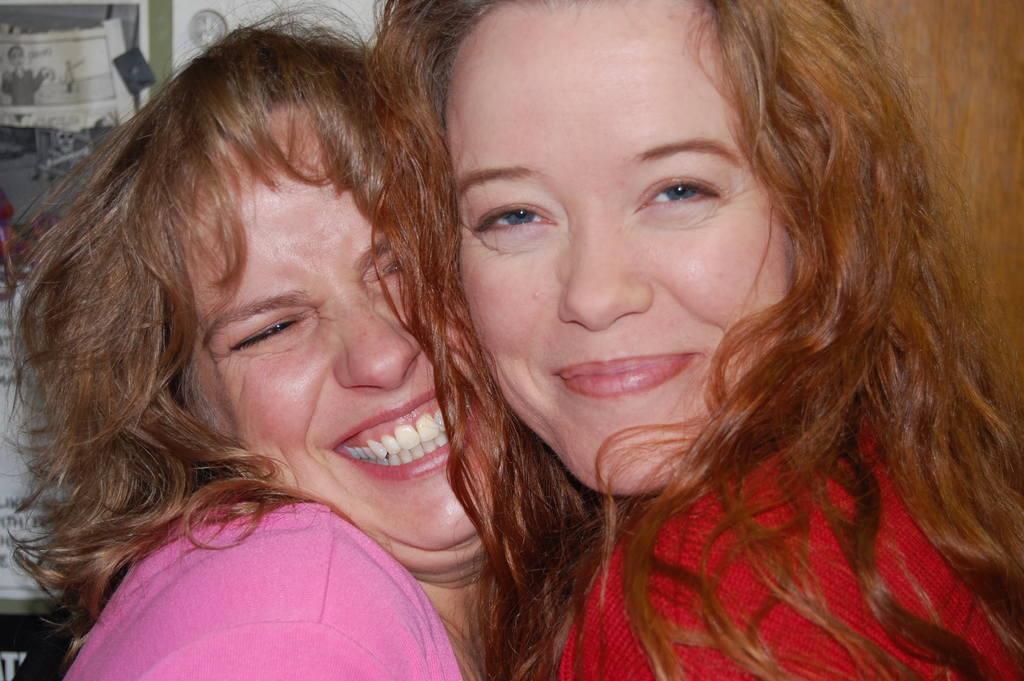Please provide a concise description of this image. Here we can see two women are smiling. In the background there is a door on the right side and there are papers on the wall. 